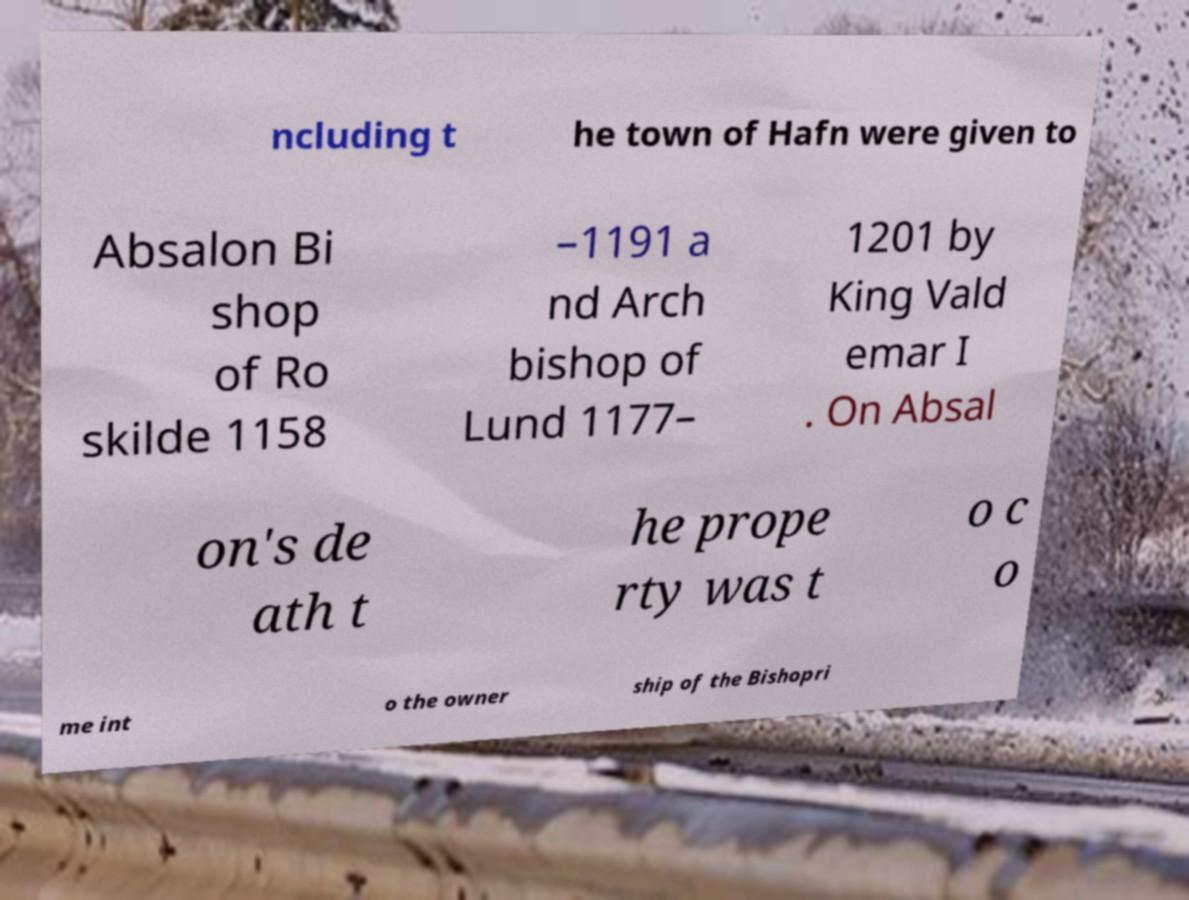I need the written content from this picture converted into text. Can you do that? ncluding t he town of Hafn were given to Absalon Bi shop of Ro skilde 1158 –1191 a nd Arch bishop of Lund 1177– 1201 by King Vald emar I . On Absal on's de ath t he prope rty was t o c o me int o the owner ship of the Bishopri 